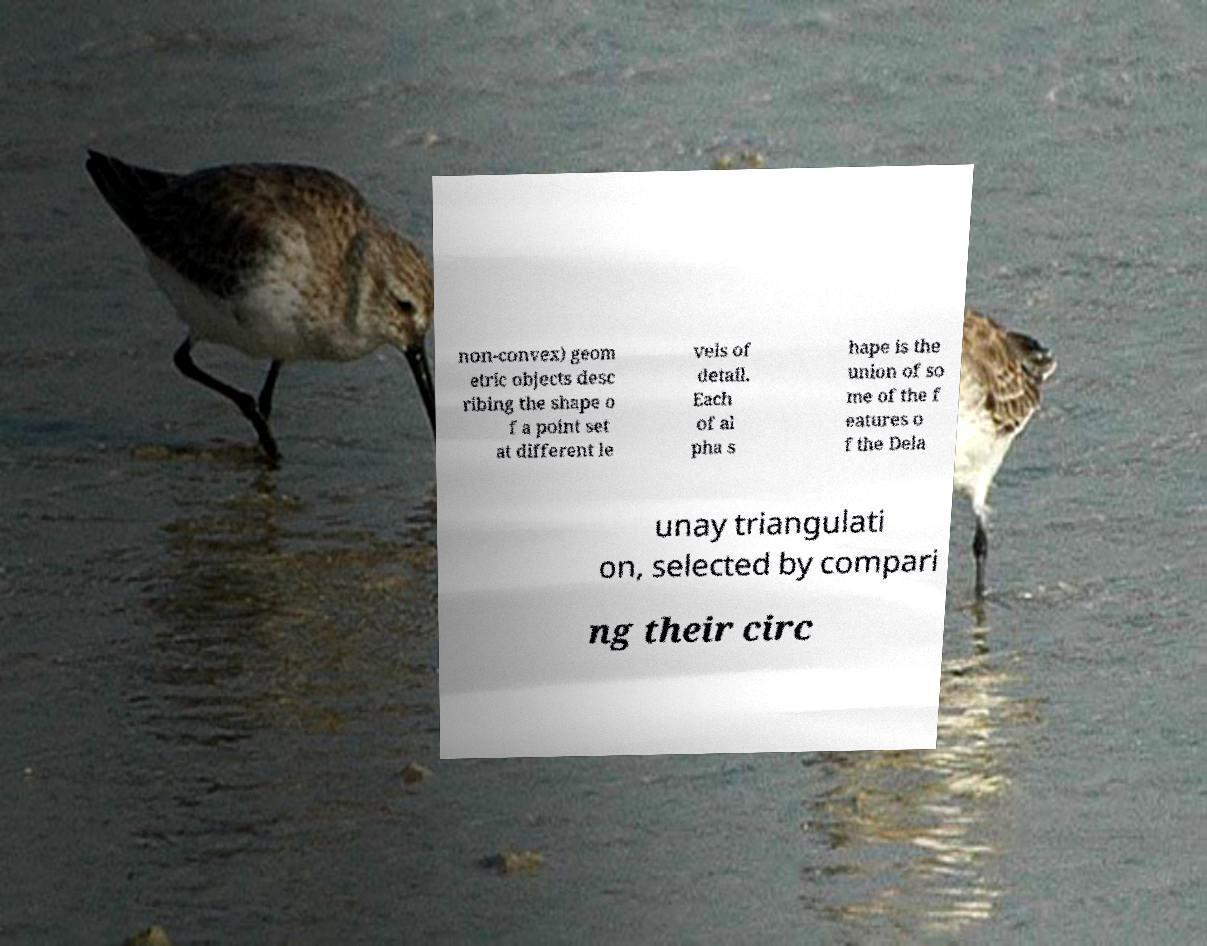Can you accurately transcribe the text from the provided image for me? non-convex) geom etric objects desc ribing the shape o f a point set at different le vels of detail. Each of al pha s hape is the union of so me of the f eatures o f the Dela unay triangulati on, selected by compari ng their circ 